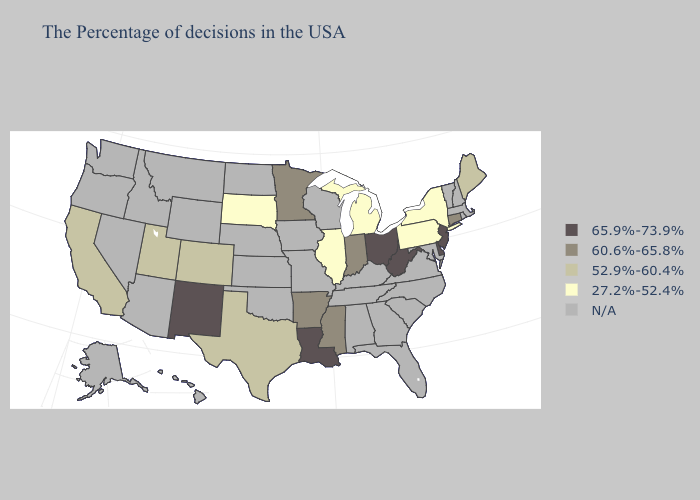Does Illinois have the lowest value in the MidWest?
Answer briefly. Yes. What is the highest value in the South ?
Write a very short answer. 65.9%-73.9%. Name the states that have a value in the range 65.9%-73.9%?
Concise answer only. New Jersey, Delaware, West Virginia, Ohio, Louisiana, New Mexico. Among the states that border Utah , which have the lowest value?
Give a very brief answer. Colorado. Name the states that have a value in the range N/A?
Short answer required. Massachusetts, Rhode Island, New Hampshire, Vermont, Maryland, Virginia, North Carolina, South Carolina, Florida, Georgia, Kentucky, Alabama, Tennessee, Wisconsin, Missouri, Iowa, Kansas, Nebraska, Oklahoma, North Dakota, Wyoming, Montana, Arizona, Idaho, Nevada, Washington, Oregon, Alaska, Hawaii. Is the legend a continuous bar?
Be succinct. No. What is the highest value in states that border Oregon?
Quick response, please. 52.9%-60.4%. What is the lowest value in the USA?
Concise answer only. 27.2%-52.4%. Name the states that have a value in the range 27.2%-52.4%?
Answer briefly. New York, Pennsylvania, Michigan, Illinois, South Dakota. Name the states that have a value in the range 52.9%-60.4%?
Answer briefly. Maine, Texas, Colorado, Utah, California. Name the states that have a value in the range 65.9%-73.9%?
Be succinct. New Jersey, Delaware, West Virginia, Ohio, Louisiana, New Mexico. Which states have the lowest value in the USA?
Short answer required. New York, Pennsylvania, Michigan, Illinois, South Dakota. What is the value of Oregon?
Concise answer only. N/A. Which states have the lowest value in the Northeast?
Quick response, please. New York, Pennsylvania. What is the value of Michigan?
Be succinct. 27.2%-52.4%. 